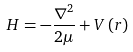Convert formula to latex. <formula><loc_0><loc_0><loc_500><loc_500>H = - \frac { \nabla ^ { 2 } } { 2 \mu } + V \left ( r \right )</formula> 